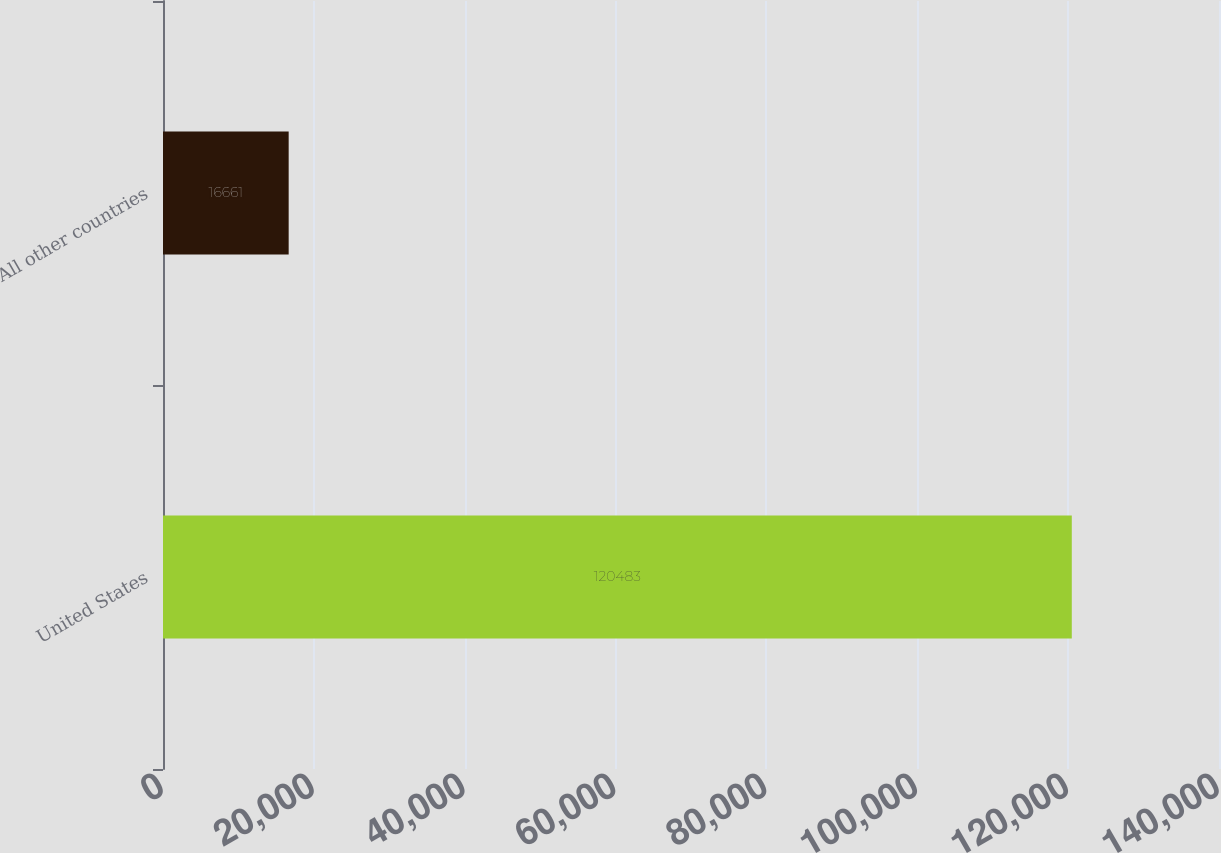Convert chart to OTSL. <chart><loc_0><loc_0><loc_500><loc_500><bar_chart><fcel>United States<fcel>All other countries<nl><fcel>120483<fcel>16661<nl></chart> 